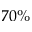<formula> <loc_0><loc_0><loc_500><loc_500>7 0 \%</formula> 